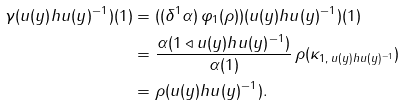<formula> <loc_0><loc_0><loc_500><loc_500>\gamma ( u ( y ) h u ( y ) ^ { - 1 } ) ( 1 ) & = ( ( \delta ^ { 1 } \alpha ) \, \varphi _ { 1 } ( \rho ) ) ( u ( y ) h u ( y ) ^ { - 1 } ) ( 1 ) \\ & = \frac { \alpha ( 1 \triangleleft u ( y ) h u ( y ) ^ { - 1 } ) } { \alpha ( 1 ) } \, \rho ( \kappa _ { 1 , \, u ( y ) h u ( y ) ^ { - 1 } } ) \\ & = \rho ( u ( y ) h u ( y ) ^ { - 1 } ) . \\</formula> 